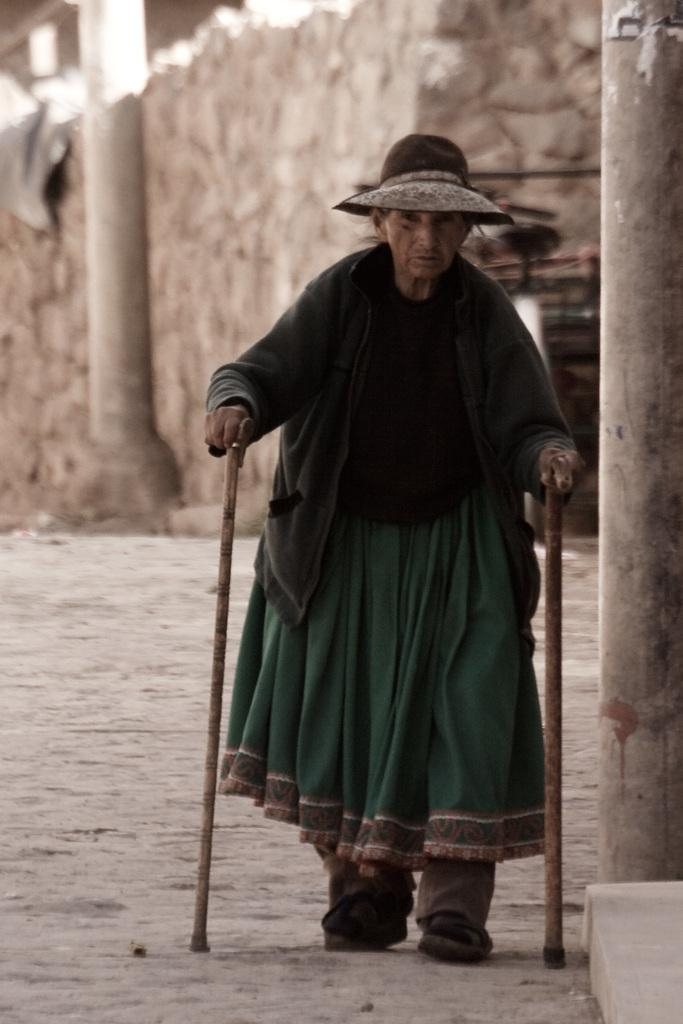Who is the main subject in the image? There is an old lady in the image. What is the old lady doing in the image? The old lady is walking on the road. What is the old lady holding while walking? The old lady is holding sticks. What can be seen in the background of the image? There is a building and pillars in the background of the image. How many children are playing with jellyfish in the image? There are no children or jellyfish present in the image. What type of jam is being spread on the bread in the image? There is no bread or jam present in the image. 